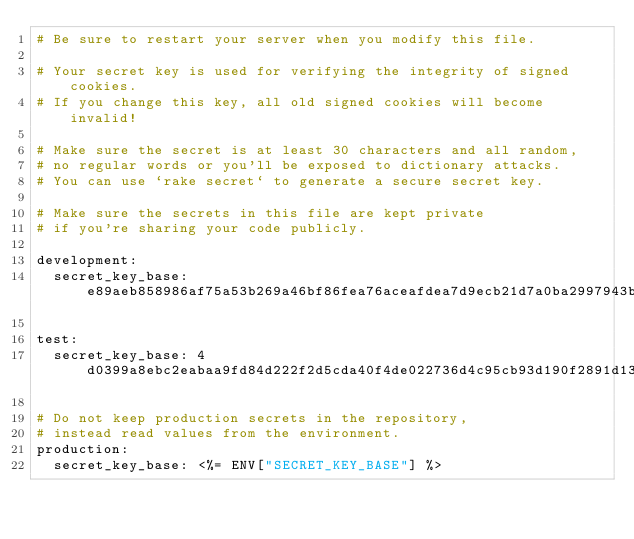<code> <loc_0><loc_0><loc_500><loc_500><_YAML_># Be sure to restart your server when you modify this file.

# Your secret key is used for verifying the integrity of signed cookies.
# If you change this key, all old signed cookies will become invalid!

# Make sure the secret is at least 30 characters and all random,
# no regular words or you'll be exposed to dictionary attacks.
# You can use `rake secret` to generate a secure secret key.

# Make sure the secrets in this file are kept private
# if you're sharing your code publicly.

development:
  secret_key_base: e89aeb858986af75a53b269a46bf86fea76aceafdea7d9ecb21d7a0ba2997943b9940d937adeceaafbdb82c02cb38491963edf518bb2c9d54c335a3dc0808dea

test:
  secret_key_base: 4d0399a8ebc2eabaa9fd84d222f2d5cda40f4de022736d4c95cb93d190f2891d13b72c362d209908d7589aceaf5094af98d3b0da242f06dd0eae1a4d924bccb9

# Do not keep production secrets in the repository,
# instead read values from the environment.
production:
  secret_key_base: <%= ENV["SECRET_KEY_BASE"] %>
</code> 